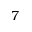<formula> <loc_0><loc_0><loc_500><loc_500>7</formula> 